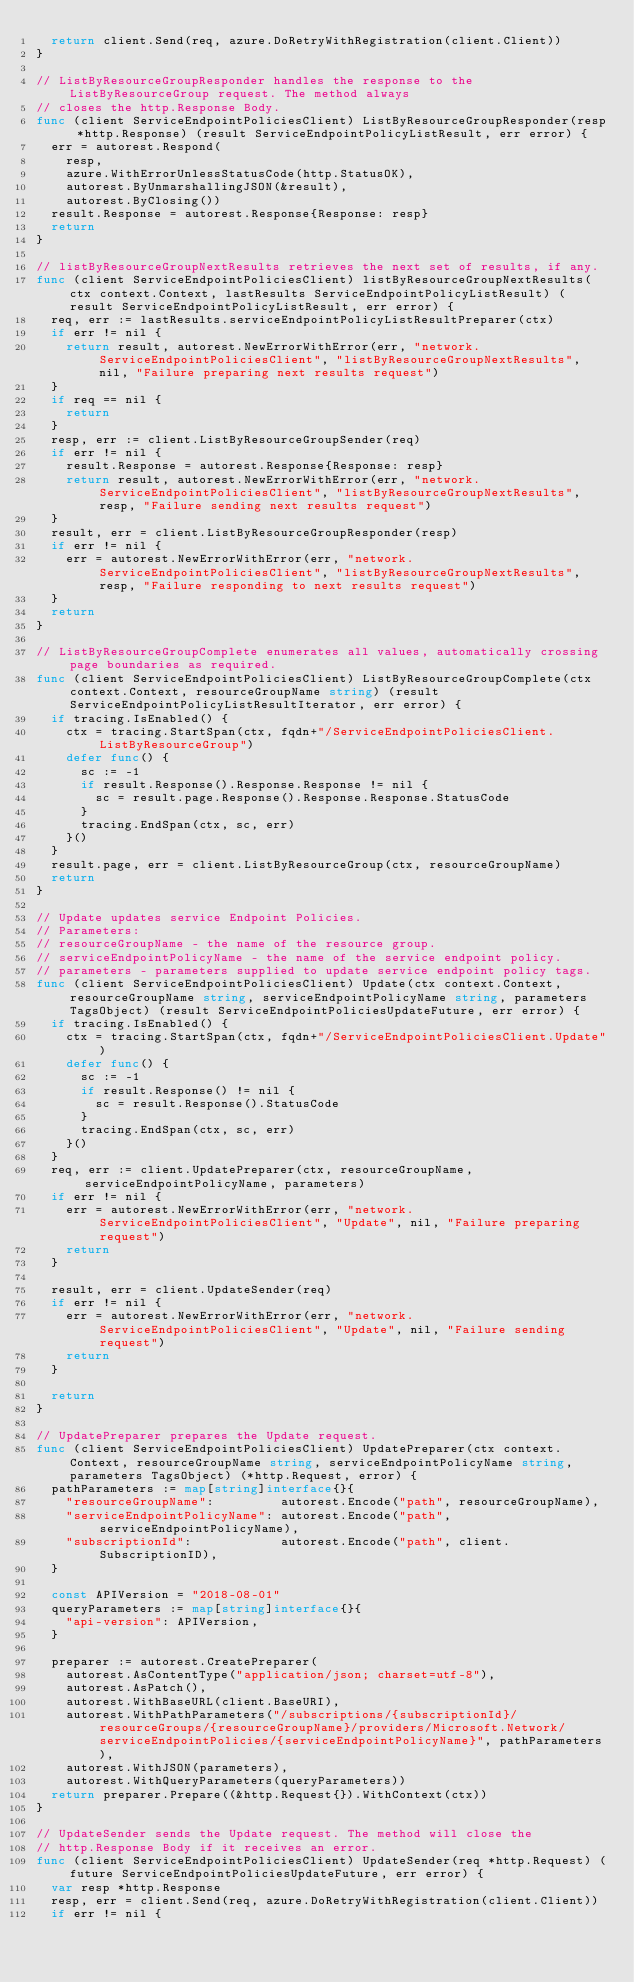Convert code to text. <code><loc_0><loc_0><loc_500><loc_500><_Go_>	return client.Send(req, azure.DoRetryWithRegistration(client.Client))
}

// ListByResourceGroupResponder handles the response to the ListByResourceGroup request. The method always
// closes the http.Response Body.
func (client ServiceEndpointPoliciesClient) ListByResourceGroupResponder(resp *http.Response) (result ServiceEndpointPolicyListResult, err error) {
	err = autorest.Respond(
		resp,
		azure.WithErrorUnlessStatusCode(http.StatusOK),
		autorest.ByUnmarshallingJSON(&result),
		autorest.ByClosing())
	result.Response = autorest.Response{Response: resp}
	return
}

// listByResourceGroupNextResults retrieves the next set of results, if any.
func (client ServiceEndpointPoliciesClient) listByResourceGroupNextResults(ctx context.Context, lastResults ServiceEndpointPolicyListResult) (result ServiceEndpointPolicyListResult, err error) {
	req, err := lastResults.serviceEndpointPolicyListResultPreparer(ctx)
	if err != nil {
		return result, autorest.NewErrorWithError(err, "network.ServiceEndpointPoliciesClient", "listByResourceGroupNextResults", nil, "Failure preparing next results request")
	}
	if req == nil {
		return
	}
	resp, err := client.ListByResourceGroupSender(req)
	if err != nil {
		result.Response = autorest.Response{Response: resp}
		return result, autorest.NewErrorWithError(err, "network.ServiceEndpointPoliciesClient", "listByResourceGroupNextResults", resp, "Failure sending next results request")
	}
	result, err = client.ListByResourceGroupResponder(resp)
	if err != nil {
		err = autorest.NewErrorWithError(err, "network.ServiceEndpointPoliciesClient", "listByResourceGroupNextResults", resp, "Failure responding to next results request")
	}
	return
}

// ListByResourceGroupComplete enumerates all values, automatically crossing page boundaries as required.
func (client ServiceEndpointPoliciesClient) ListByResourceGroupComplete(ctx context.Context, resourceGroupName string) (result ServiceEndpointPolicyListResultIterator, err error) {
	if tracing.IsEnabled() {
		ctx = tracing.StartSpan(ctx, fqdn+"/ServiceEndpointPoliciesClient.ListByResourceGroup")
		defer func() {
			sc := -1
			if result.Response().Response.Response != nil {
				sc = result.page.Response().Response.Response.StatusCode
			}
			tracing.EndSpan(ctx, sc, err)
		}()
	}
	result.page, err = client.ListByResourceGroup(ctx, resourceGroupName)
	return
}

// Update updates service Endpoint Policies.
// Parameters:
// resourceGroupName - the name of the resource group.
// serviceEndpointPolicyName - the name of the service endpoint policy.
// parameters - parameters supplied to update service endpoint policy tags.
func (client ServiceEndpointPoliciesClient) Update(ctx context.Context, resourceGroupName string, serviceEndpointPolicyName string, parameters TagsObject) (result ServiceEndpointPoliciesUpdateFuture, err error) {
	if tracing.IsEnabled() {
		ctx = tracing.StartSpan(ctx, fqdn+"/ServiceEndpointPoliciesClient.Update")
		defer func() {
			sc := -1
			if result.Response() != nil {
				sc = result.Response().StatusCode
			}
			tracing.EndSpan(ctx, sc, err)
		}()
	}
	req, err := client.UpdatePreparer(ctx, resourceGroupName, serviceEndpointPolicyName, parameters)
	if err != nil {
		err = autorest.NewErrorWithError(err, "network.ServiceEndpointPoliciesClient", "Update", nil, "Failure preparing request")
		return
	}

	result, err = client.UpdateSender(req)
	if err != nil {
		err = autorest.NewErrorWithError(err, "network.ServiceEndpointPoliciesClient", "Update", nil, "Failure sending request")
		return
	}

	return
}

// UpdatePreparer prepares the Update request.
func (client ServiceEndpointPoliciesClient) UpdatePreparer(ctx context.Context, resourceGroupName string, serviceEndpointPolicyName string, parameters TagsObject) (*http.Request, error) {
	pathParameters := map[string]interface{}{
		"resourceGroupName":         autorest.Encode("path", resourceGroupName),
		"serviceEndpointPolicyName": autorest.Encode("path", serviceEndpointPolicyName),
		"subscriptionId":            autorest.Encode("path", client.SubscriptionID),
	}

	const APIVersion = "2018-08-01"
	queryParameters := map[string]interface{}{
		"api-version": APIVersion,
	}

	preparer := autorest.CreatePreparer(
		autorest.AsContentType("application/json; charset=utf-8"),
		autorest.AsPatch(),
		autorest.WithBaseURL(client.BaseURI),
		autorest.WithPathParameters("/subscriptions/{subscriptionId}/resourceGroups/{resourceGroupName}/providers/Microsoft.Network/serviceEndpointPolicies/{serviceEndpointPolicyName}", pathParameters),
		autorest.WithJSON(parameters),
		autorest.WithQueryParameters(queryParameters))
	return preparer.Prepare((&http.Request{}).WithContext(ctx))
}

// UpdateSender sends the Update request. The method will close the
// http.Response Body if it receives an error.
func (client ServiceEndpointPoliciesClient) UpdateSender(req *http.Request) (future ServiceEndpointPoliciesUpdateFuture, err error) {
	var resp *http.Response
	resp, err = client.Send(req, azure.DoRetryWithRegistration(client.Client))
	if err != nil {</code> 